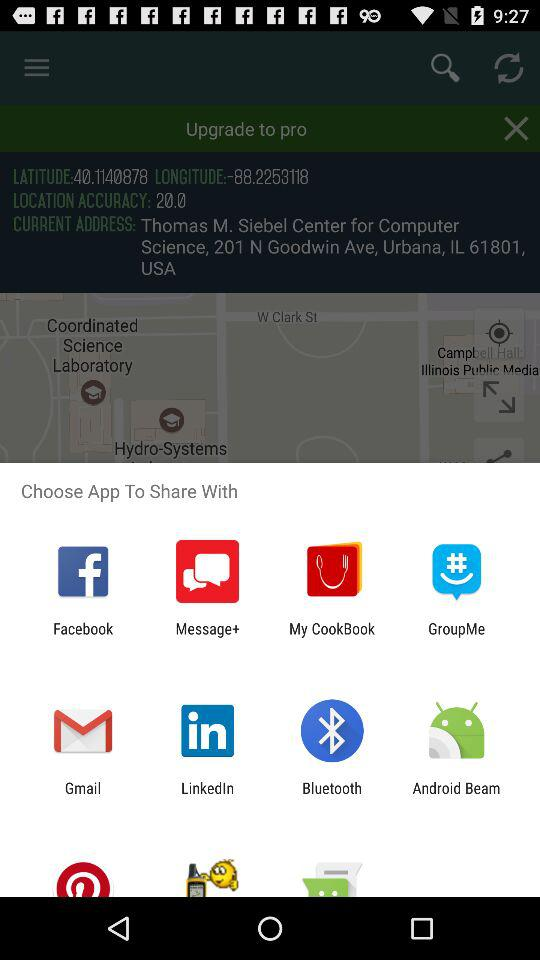With which application can we share the content? You can share the content with "Facebook", "Message+", "My CookBook", "GroupMe", "Gmail", "LinkedIn", "Bluetooth" and "Android Beam". 